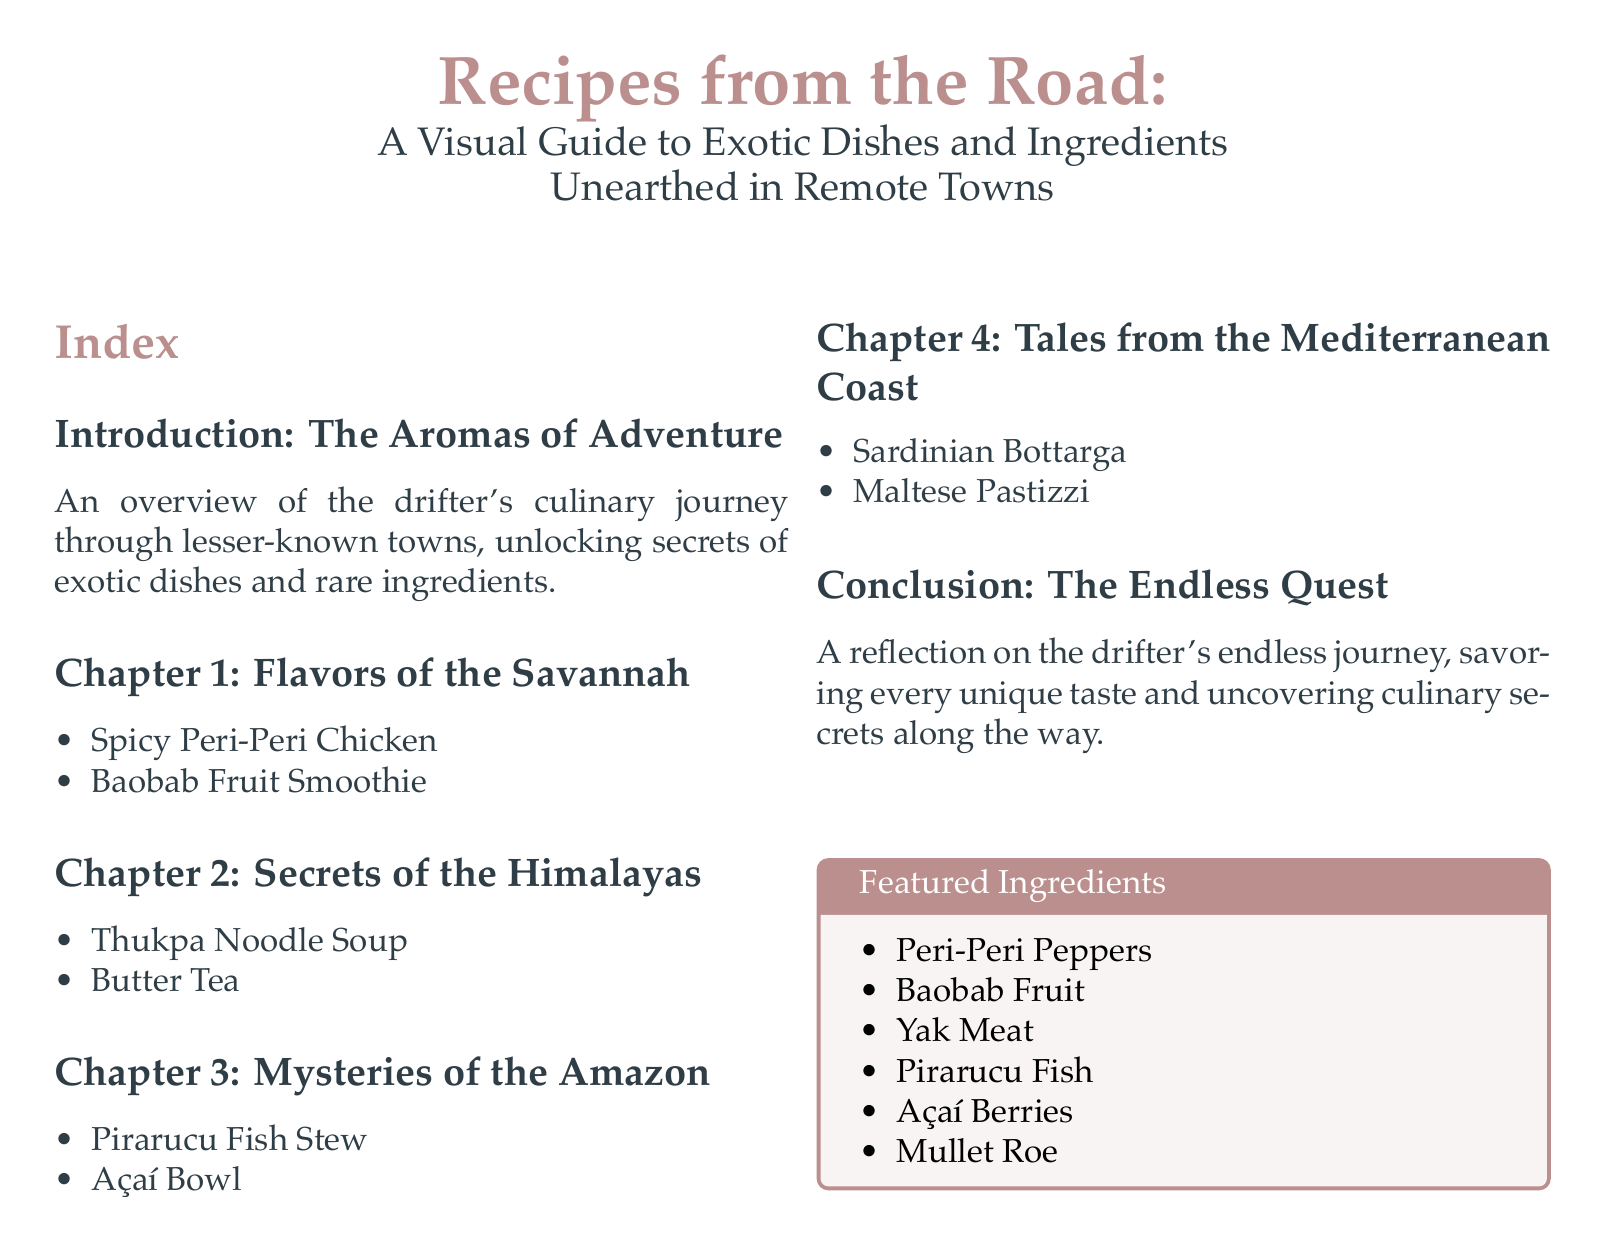What is the title of the document? The title is the heading of the document, which introduces its main theme.
Answer: Recipes from the Road How many chapters are in the document? The number of chapters is indicated in the index section as separate entries.
Answer: 4 What dish is featured in Chapter 1? Chapter 1 lists specific dishes under its title, with one of them being the featured dish.
Answer: Spicy Peri-Peri Chicken Which fruit is highlighted in the Featured Ingredients box? The box lists specific ingredients which can be identified directly as part of its contents.
Answer: Baobab Fruit What type of tea is mentioned in Chapter 2? Chapter 2 includes specific dishes, one of which is a type of beverage.
Answer: Butter Tea What is the setting of Chapter 3? The chapter's title indicates the geographical area it covers, relating to its culinary exploration.
Answer: Amazon How many ingredients are listed in the Featured Ingredients box? The total number of items in the box can be counted directly from the document.
Answer: 6 What dish is found in the Mediterranean Coast chapter? This chapter is specifically titled and lists unique dishes relevant to that region.
Answer: Maltese Pastizzi What overarching theme is addressed in the Conclusion? The conclusion summarizes the main reflective idea related to the journey portrayed in the document.
Answer: Endless journey 